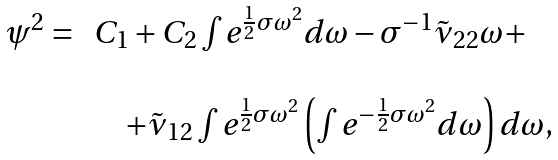Convert formula to latex. <formula><loc_0><loc_0><loc_500><loc_500>\begin{array} { l l } \psi ^ { 2 } = \, & C _ { 1 } + C _ { 2 } \int e ^ { \frac { 1 } { 2 } \sigma \omega ^ { 2 } } d \omega - \sigma ^ { - 1 } \tilde { \nu } _ { 2 2 } \omega + \\ \\ & \quad + \tilde { \nu } _ { 1 2 } \int e ^ { \frac { 1 } { 2 } \sigma \omega ^ { 2 } } \left ( \int e ^ { - \frac { 1 } { 2 } \sigma \omega ^ { 2 } } d \omega \right ) d \omega , \end{array}</formula> 